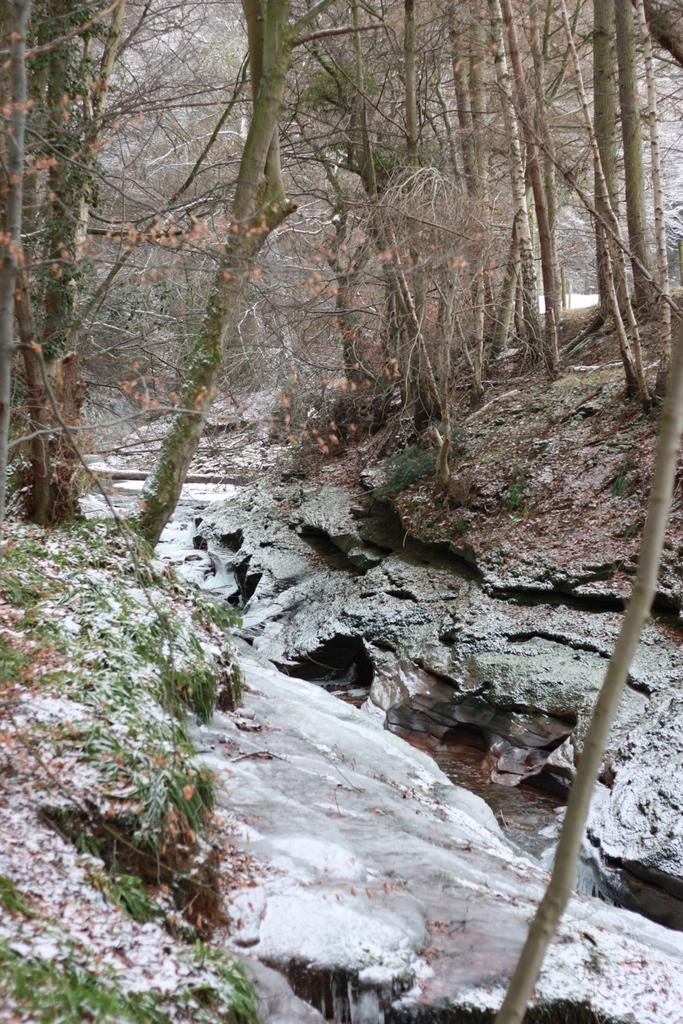What type of vegetation can be seen in the image? There are trees in the image. What type of ground cover is present in the image? There is grass in the image. What type of terrain is visible in the image? There is mud in the image. What type of weather condition is depicted in the image? There is snow in the image. What is visible in the background of the image? There is a sky visible in the image. What type of food is being served to the donkey in the image? There is no donkey or food present in the image. What type of attraction can be seen in the image? There is no attraction present in the image; it features natural elements such as trees, grass, mud, snow, and sky. 